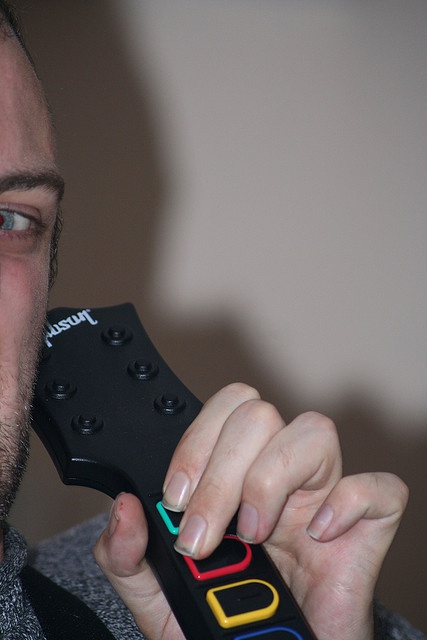Describe the objects in this image and their specific colors. I can see people in black, darkgray, and gray tones and remote in black, maroon, and gray tones in this image. 